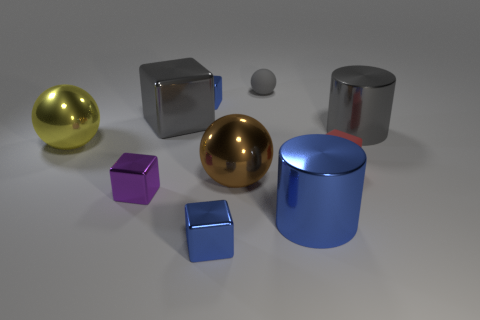Subtract all gray blocks. How many blocks are left? 4 Subtract all brown balls. Subtract all green blocks. How many balls are left? 2 Subtract all balls. How many objects are left? 7 Subtract 1 gray blocks. How many objects are left? 9 Subtract all big cubes. Subtract all purple metallic blocks. How many objects are left? 8 Add 8 gray shiny objects. How many gray shiny objects are left? 10 Add 7 small gray things. How many small gray things exist? 8 